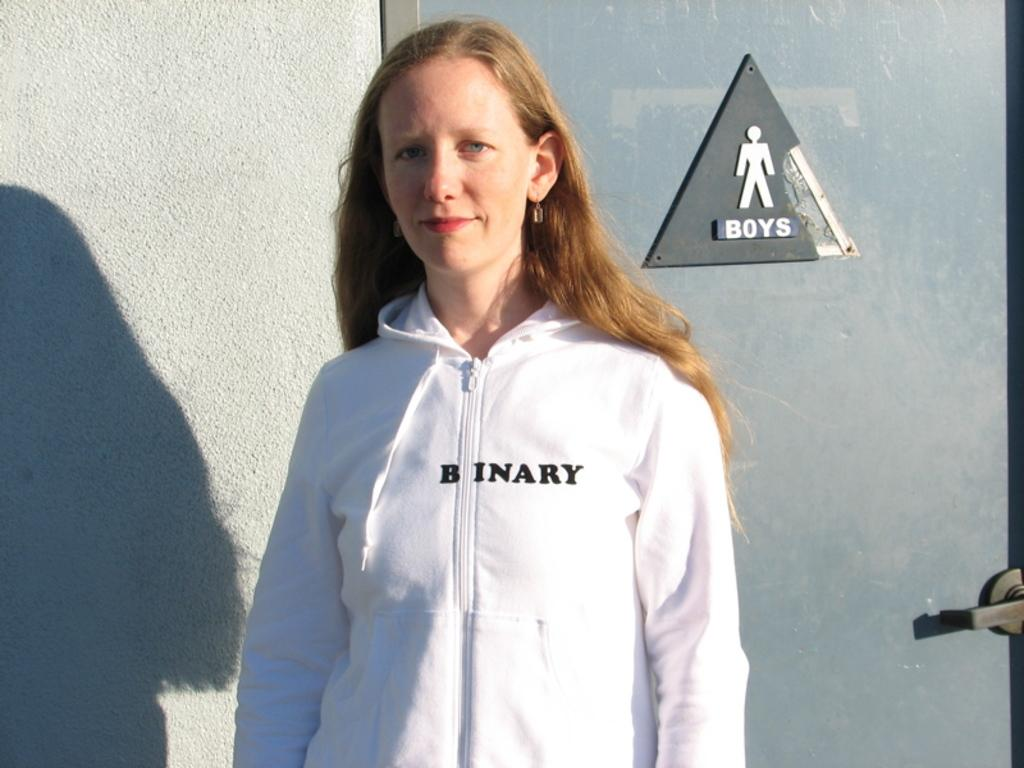<image>
Provide a brief description of the given image. The woman is standing in front of the boys bathroom. 